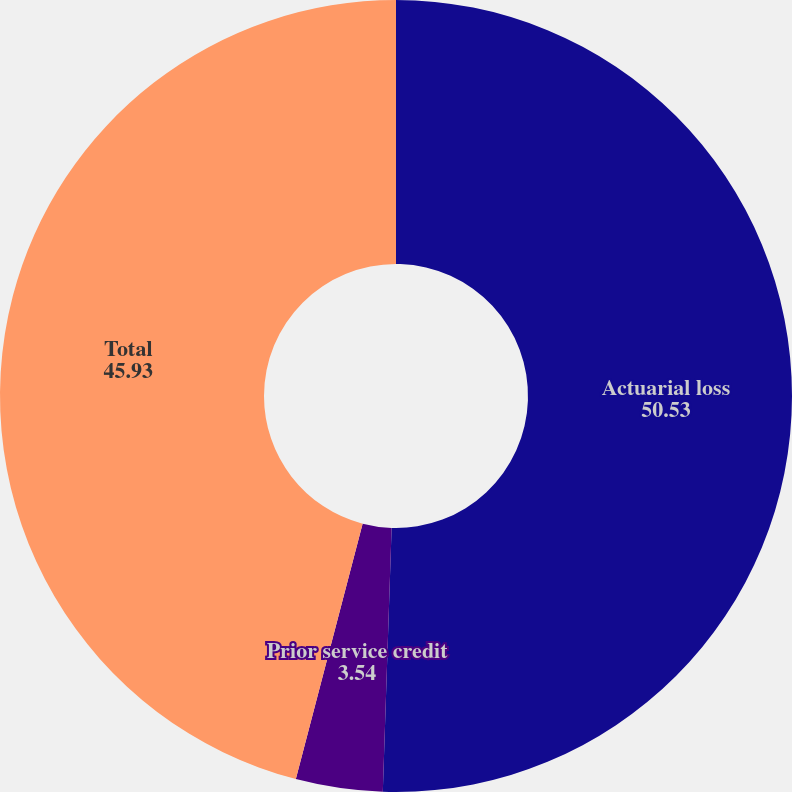Convert chart to OTSL. <chart><loc_0><loc_0><loc_500><loc_500><pie_chart><fcel>Actuarial loss<fcel>Prior service credit<fcel>Total<nl><fcel>50.53%<fcel>3.54%<fcel>45.93%<nl></chart> 